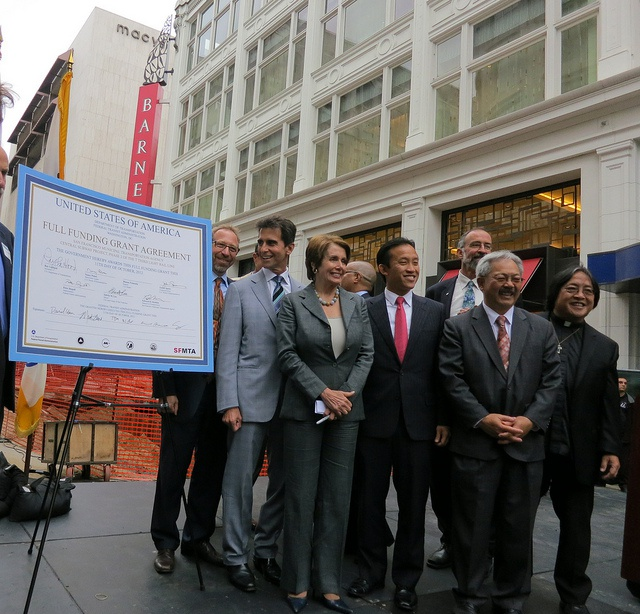Describe the objects in this image and their specific colors. I can see people in white, black, gray, brown, and maroon tones, people in white, black, gray, and purple tones, people in white, black, gray, maroon, and darkgray tones, people in white, black, gray, and darkblue tones, and people in white, black, gray, and maroon tones in this image. 